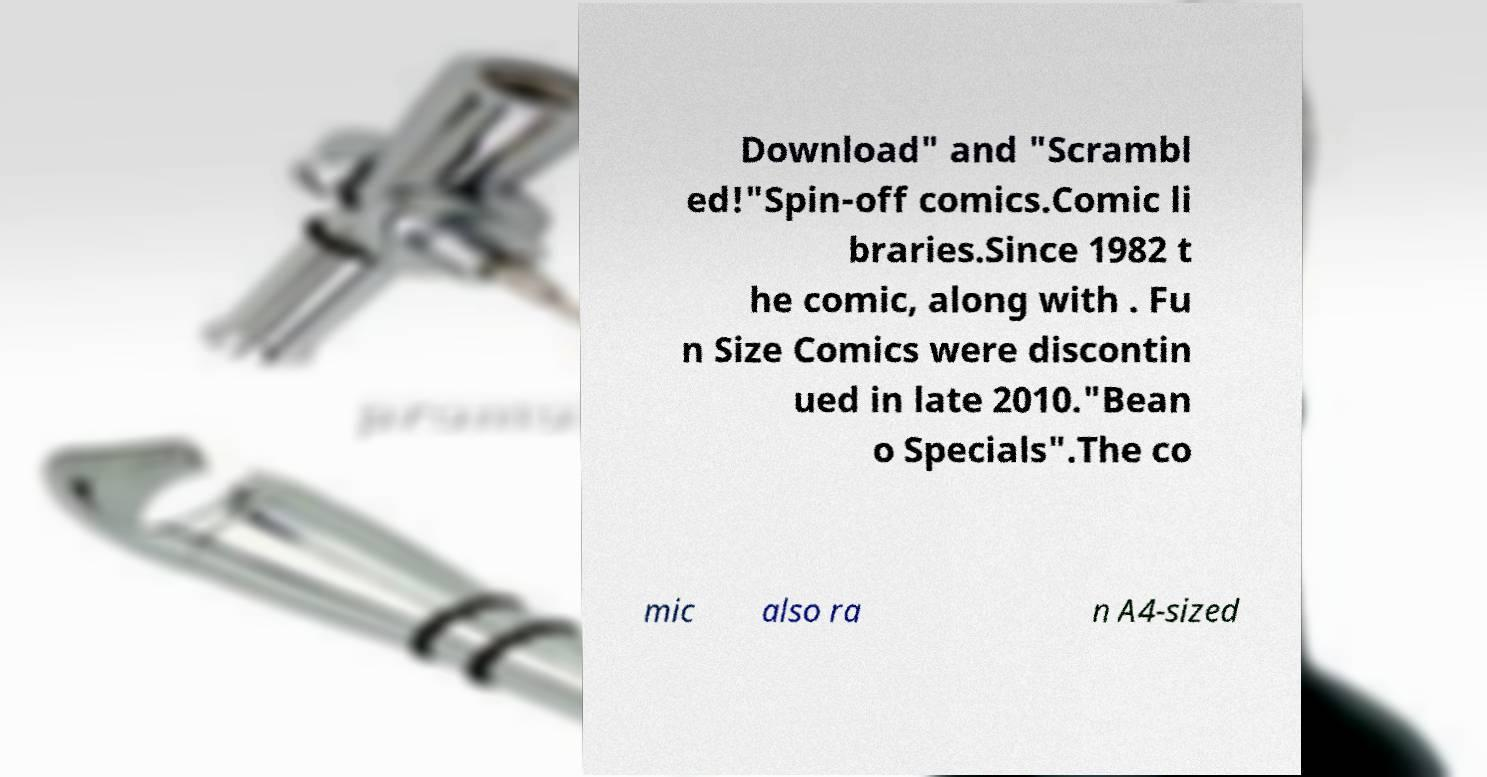I need the written content from this picture converted into text. Can you do that? Download" and "Scrambl ed!"Spin-off comics.Comic li braries.Since 1982 t he comic, along with . Fu n Size Comics were discontin ued in late 2010."Bean o Specials".The co mic also ra n A4-sized 